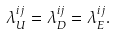<formula> <loc_0><loc_0><loc_500><loc_500>\lambda ^ { i j } _ { U } = \lambda ^ { i j } _ { D } = \lambda ^ { i j } _ { E } .</formula> 